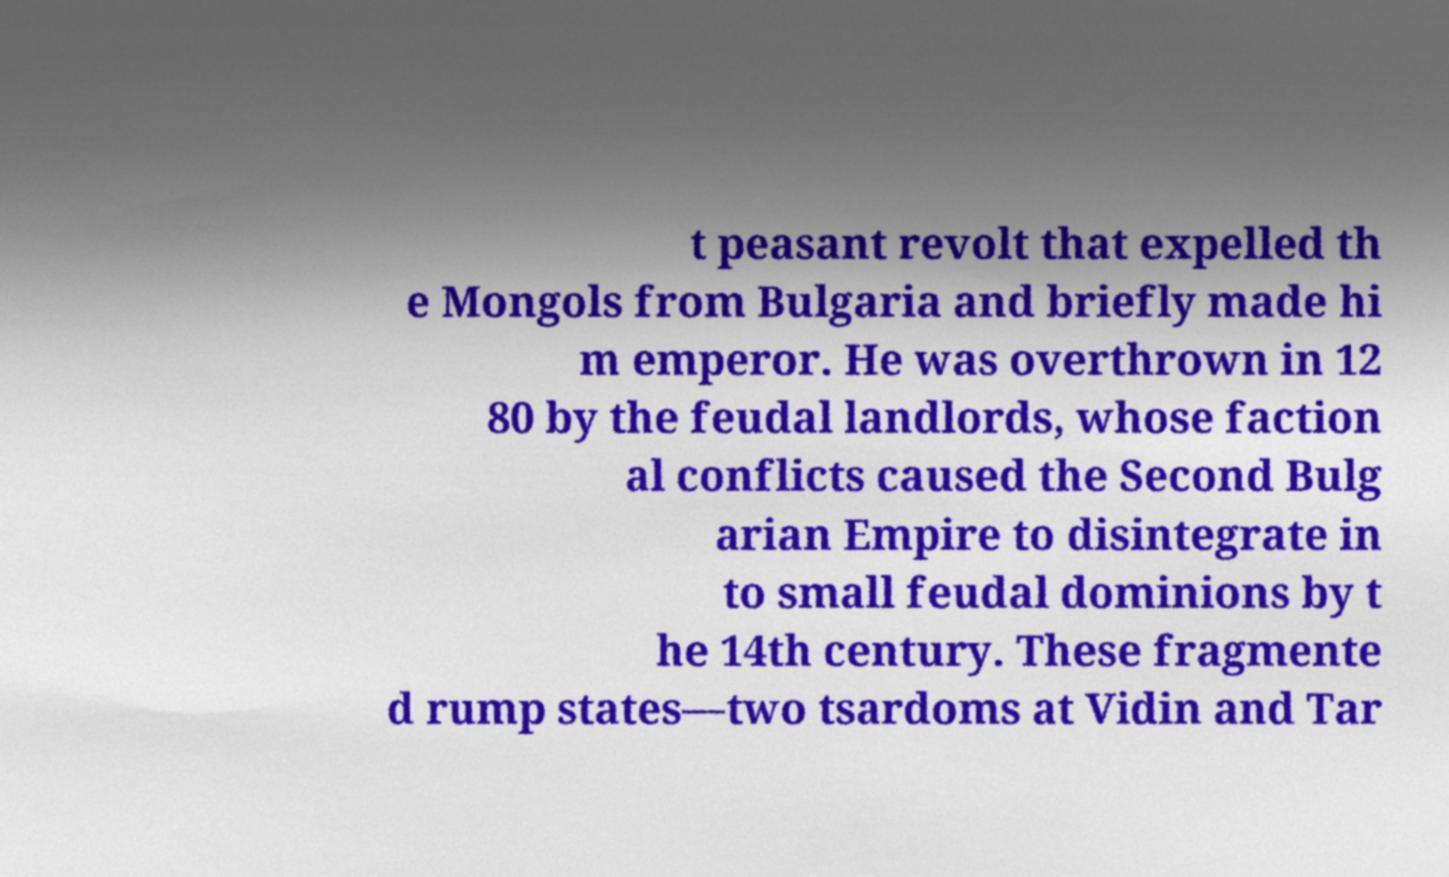Can you read and provide the text displayed in the image?This photo seems to have some interesting text. Can you extract and type it out for me? t peasant revolt that expelled th e Mongols from Bulgaria and briefly made hi m emperor. He was overthrown in 12 80 by the feudal landlords, whose faction al conflicts caused the Second Bulg arian Empire to disintegrate in to small feudal dominions by t he 14th century. These fragmente d rump states—two tsardoms at Vidin and Tar 